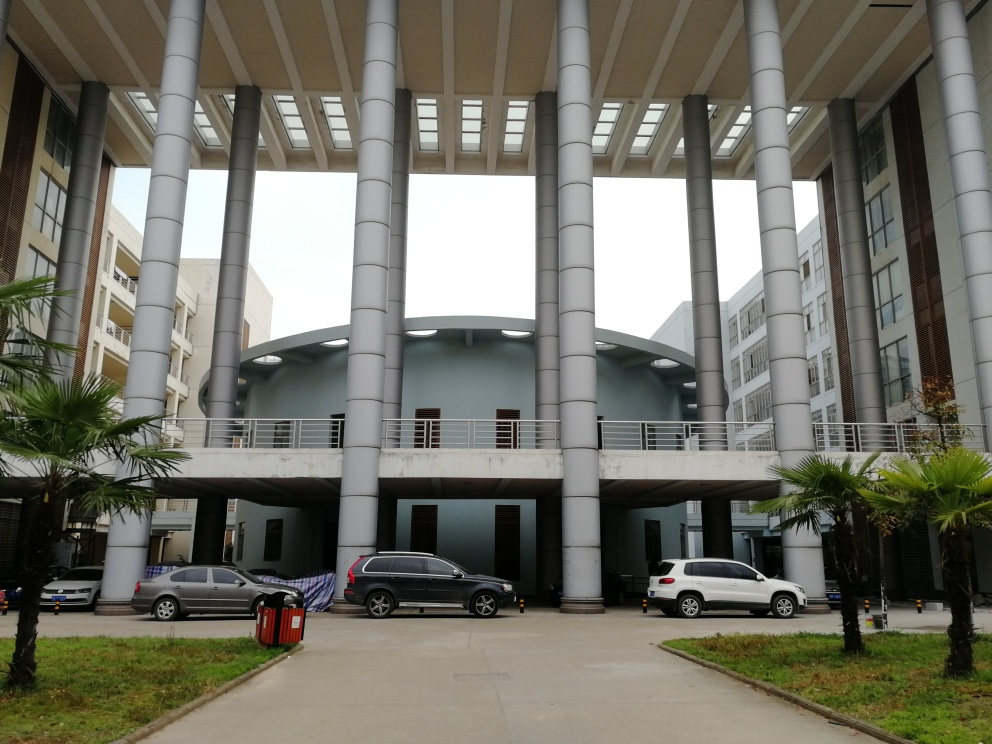Could you describe the architectural style and elements visible in this image? The image showcases a modern architectural style with functional design elements. Notable features include large cylindrical columns supporting an overhanging structure, a flat canopy with integrated lighting, and a mix of rounded and angular shapes in the design of the buildings. The use of glass and metal materials is evident, contrasting with the organic textures of the palm trees in the foreground. 